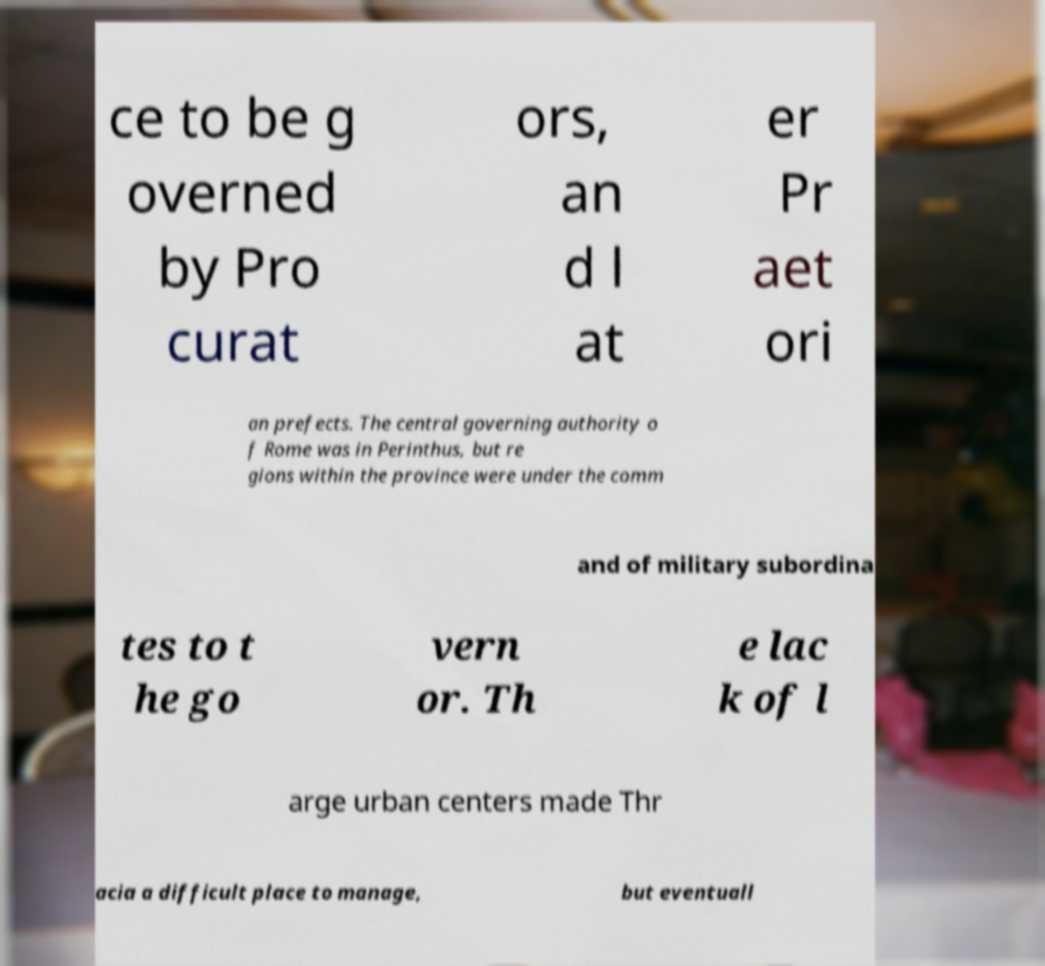Could you assist in decoding the text presented in this image and type it out clearly? ce to be g overned by Pro curat ors, an d l at er Pr aet ori an prefects. The central governing authority o f Rome was in Perinthus, but re gions within the province were under the comm and of military subordina tes to t he go vern or. Th e lac k of l arge urban centers made Thr acia a difficult place to manage, but eventuall 